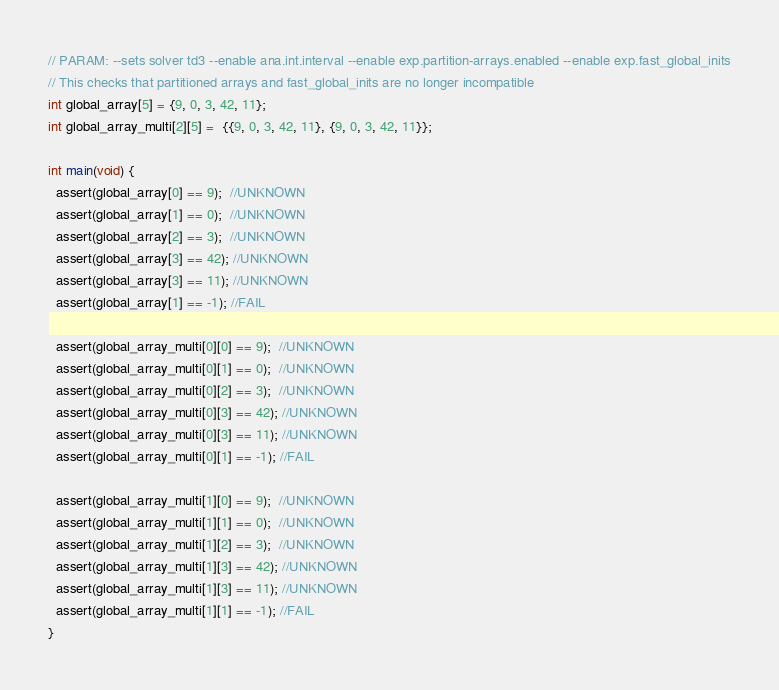<code> <loc_0><loc_0><loc_500><loc_500><_C_>// PARAM: --sets solver td3 --enable ana.int.interval --enable exp.partition-arrays.enabled --enable exp.fast_global_inits
// This checks that partitioned arrays and fast_global_inits are no longer incompatible
int global_array[5] = {9, 0, 3, 42, 11};
int global_array_multi[2][5] =  {{9, 0, 3, 42, 11}, {9, 0, 3, 42, 11}};

int main(void) {
  assert(global_array[0] == 9);  //UNKNOWN
  assert(global_array[1] == 0);  //UNKNOWN
  assert(global_array[2] == 3);  //UNKNOWN
  assert(global_array[3] == 42); //UNKNOWN
  assert(global_array[3] == 11); //UNKNOWN
  assert(global_array[1] == -1); //FAIL

  assert(global_array_multi[0][0] == 9);  //UNKNOWN
  assert(global_array_multi[0][1] == 0);  //UNKNOWN
  assert(global_array_multi[0][2] == 3);  //UNKNOWN
  assert(global_array_multi[0][3] == 42); //UNKNOWN
  assert(global_array_multi[0][3] == 11); //UNKNOWN
  assert(global_array_multi[0][1] == -1); //FAIL

  assert(global_array_multi[1][0] == 9);  //UNKNOWN
  assert(global_array_multi[1][1] == 0);  //UNKNOWN
  assert(global_array_multi[1][2] == 3);  //UNKNOWN
  assert(global_array_multi[1][3] == 42); //UNKNOWN
  assert(global_array_multi[1][3] == 11); //UNKNOWN
  assert(global_array_multi[1][1] == -1); //FAIL
}
</code> 